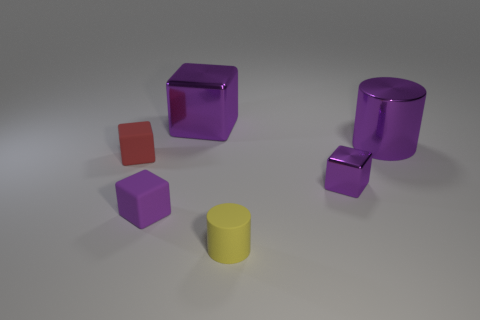What number of purple shiny things have the same shape as the yellow object?
Provide a succinct answer. 1. Do the rubber block that is on the left side of the tiny purple rubber thing and the purple shiny object to the left of the tiny purple metal thing have the same size?
Your answer should be very brief. No. There is a purple metal thing that is left of the tiny purple object that is right of the large metallic block; what shape is it?
Your response must be concise. Cube. Are there the same number of yellow things that are to the right of the yellow matte object and large purple blocks?
Provide a succinct answer. No. What is the big purple object that is on the right side of the tiny rubber thing in front of the matte block that is to the right of the tiny red matte cube made of?
Your response must be concise. Metal. Are there any other yellow matte cylinders of the same size as the yellow cylinder?
Give a very brief answer. No. What shape is the yellow rubber object?
Your answer should be very brief. Cylinder. How many balls are either large purple metal things or red things?
Keep it short and to the point. 0. Are there the same number of big purple things right of the tiny rubber cylinder and red matte cubes that are in front of the purple metal cylinder?
Provide a short and direct response. Yes. There is a large object that is right of the purple metal cube that is in front of the tiny red rubber object; how many yellow cylinders are in front of it?
Your response must be concise. 1. 